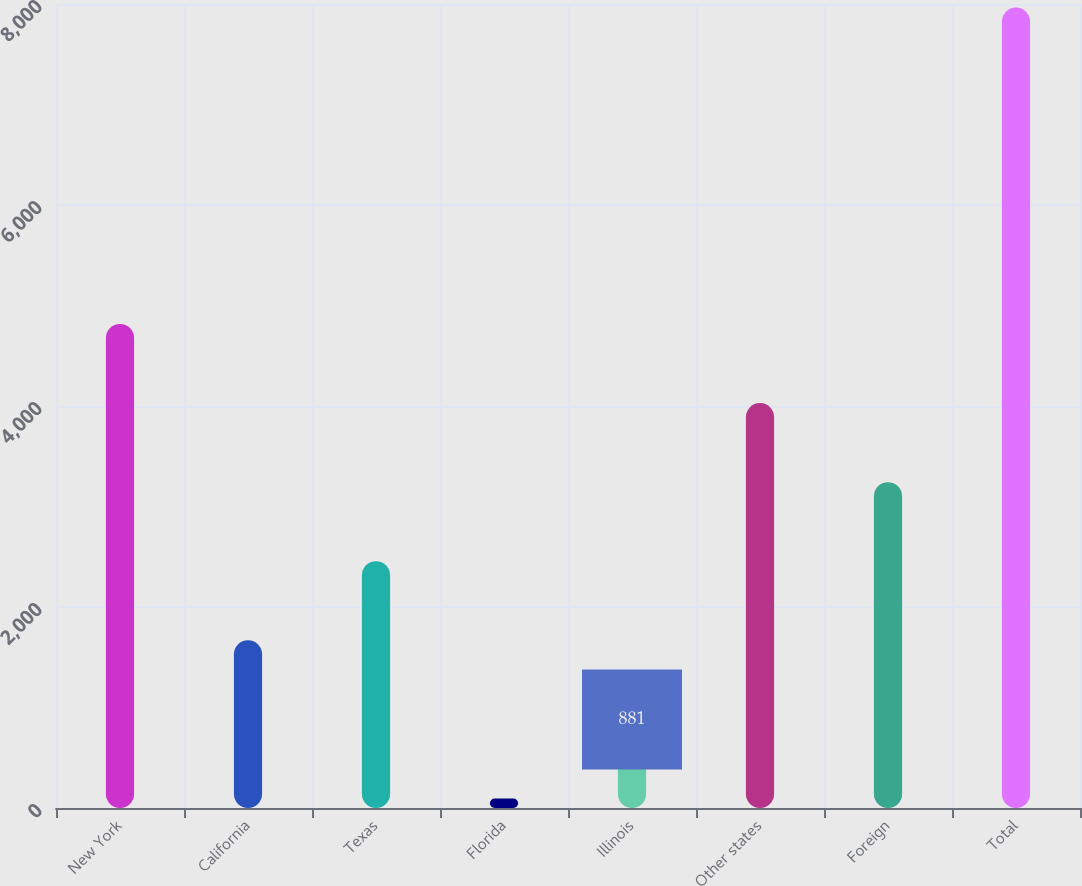<chart> <loc_0><loc_0><loc_500><loc_500><bar_chart><fcel>New York<fcel>California<fcel>Texas<fcel>Florida<fcel>Illinois<fcel>Other states<fcel>Foreign<fcel>Total<nl><fcel>4816<fcel>1668<fcel>2455<fcel>94<fcel>881<fcel>4029<fcel>3242<fcel>7964<nl></chart> 